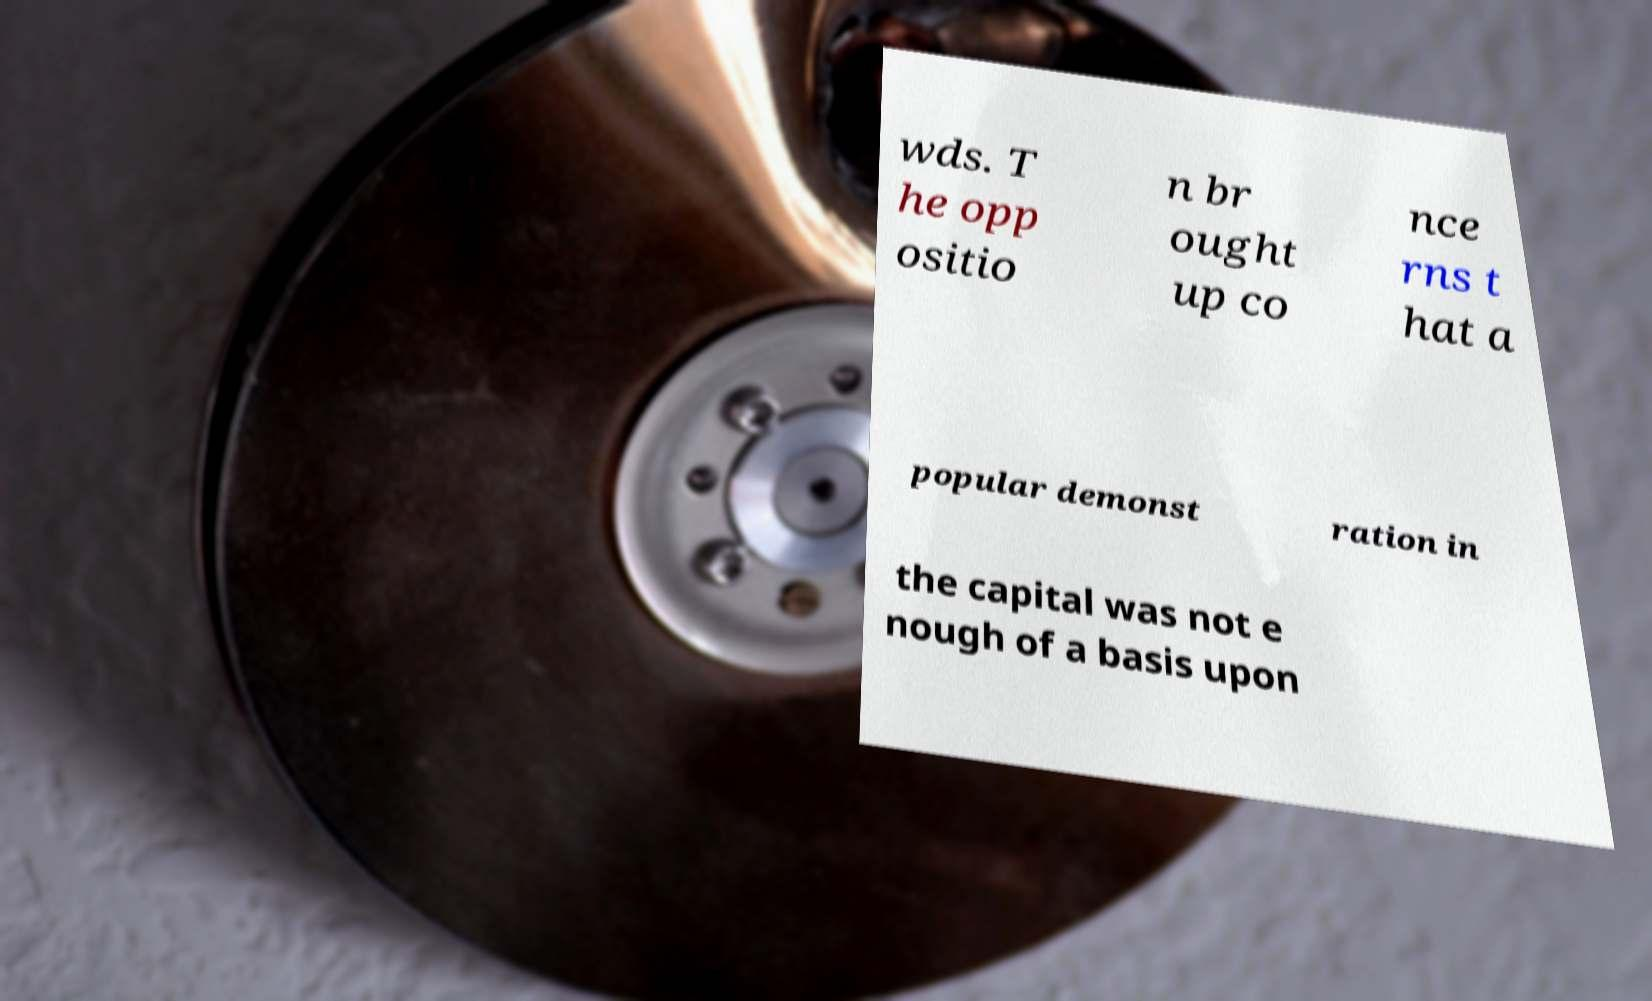What messages or text are displayed in this image? I need them in a readable, typed format. wds. T he opp ositio n br ought up co nce rns t hat a popular demonst ration in the capital was not e nough of a basis upon 